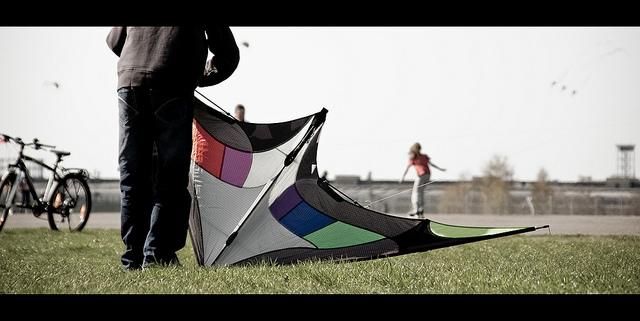Is the man standing?
Keep it brief. Yes. How many recreational activities are represented here?
Keep it brief. 3. Did the kite commit suicide?
Short answer required. No. Does the person with the kite have a head?
Keep it brief. Yes. 